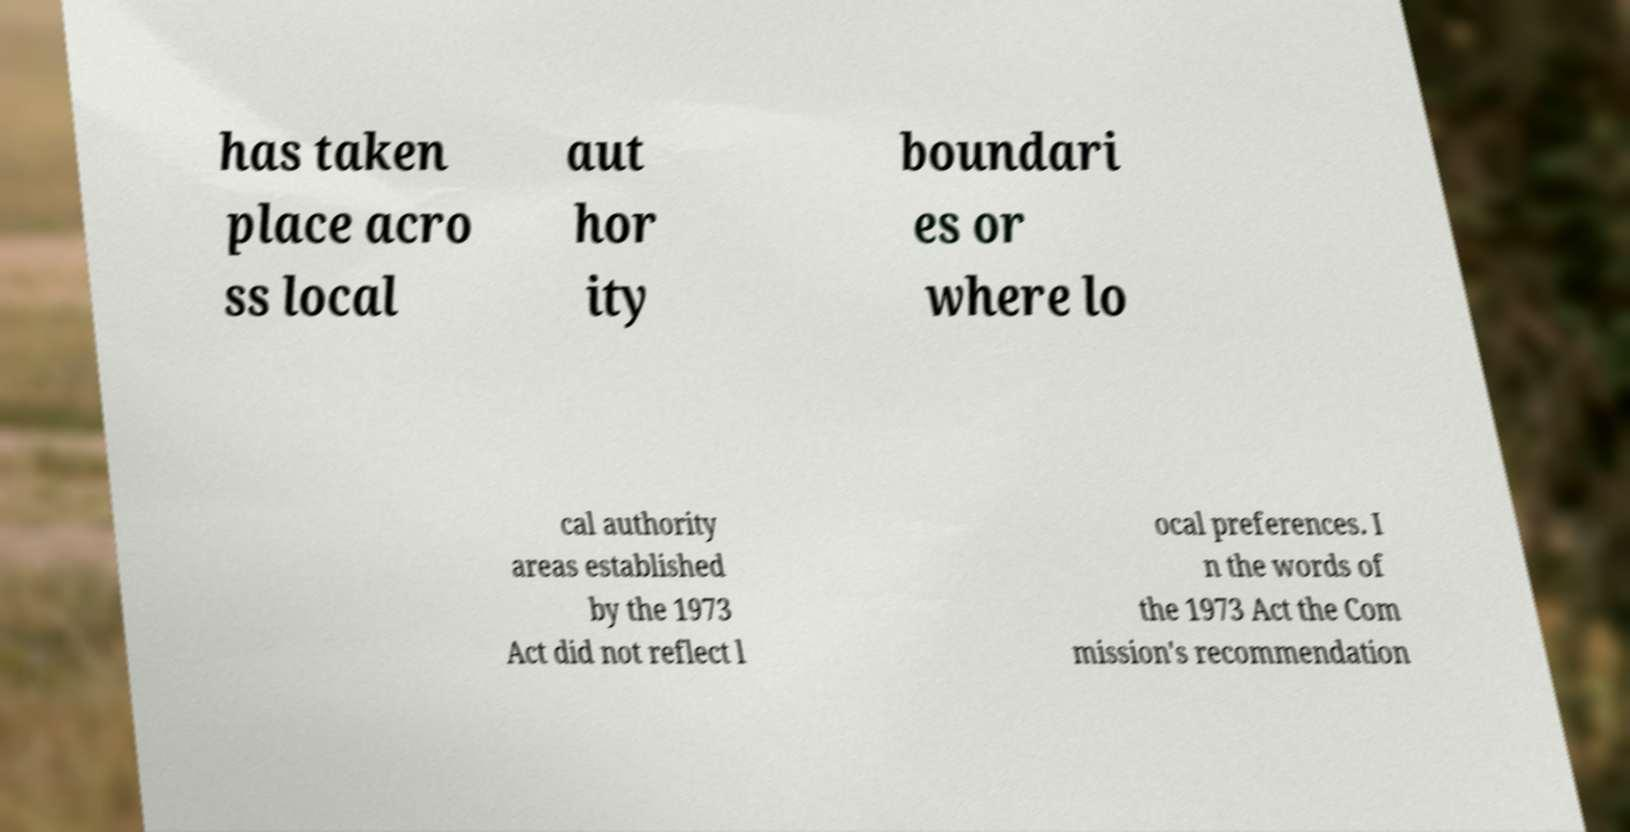Please identify and transcribe the text found in this image. has taken place acro ss local aut hor ity boundari es or where lo cal authority areas established by the 1973 Act did not reflect l ocal preferences. I n the words of the 1973 Act the Com mission's recommendation 